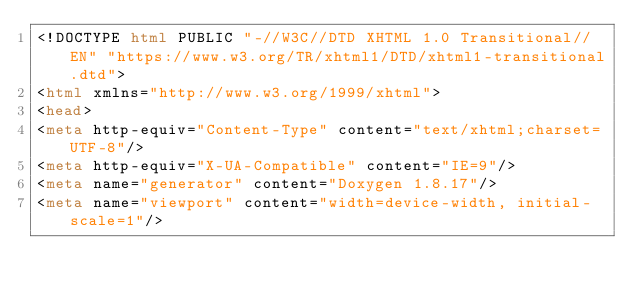Convert code to text. <code><loc_0><loc_0><loc_500><loc_500><_HTML_><!DOCTYPE html PUBLIC "-//W3C//DTD XHTML 1.0 Transitional//EN" "https://www.w3.org/TR/xhtml1/DTD/xhtml1-transitional.dtd">
<html xmlns="http://www.w3.org/1999/xhtml">
<head>
<meta http-equiv="Content-Type" content="text/xhtml;charset=UTF-8"/>
<meta http-equiv="X-UA-Compatible" content="IE=9"/>
<meta name="generator" content="Doxygen 1.8.17"/>
<meta name="viewport" content="width=device-width, initial-scale=1"/></code> 